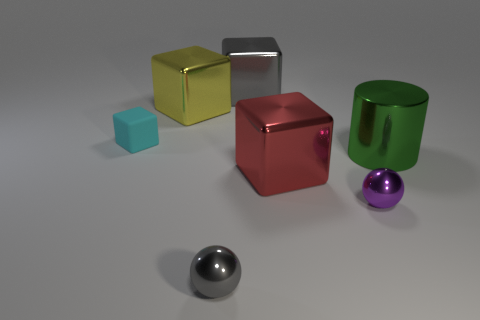Subtract all yellow blocks. How many blocks are left? 3 Add 1 tiny gray things. How many objects exist? 8 Subtract all yellow blocks. How many blocks are left? 3 Subtract 1 balls. How many balls are left? 1 Subtract all brown spheres. Subtract all red cubes. How many spheres are left? 2 Subtract all purple cubes. How many gray cylinders are left? 0 Subtract all tiny red metal cylinders. Subtract all big objects. How many objects are left? 3 Add 1 cyan things. How many cyan things are left? 2 Add 4 purple balls. How many purple balls exist? 5 Subtract 0 green blocks. How many objects are left? 7 